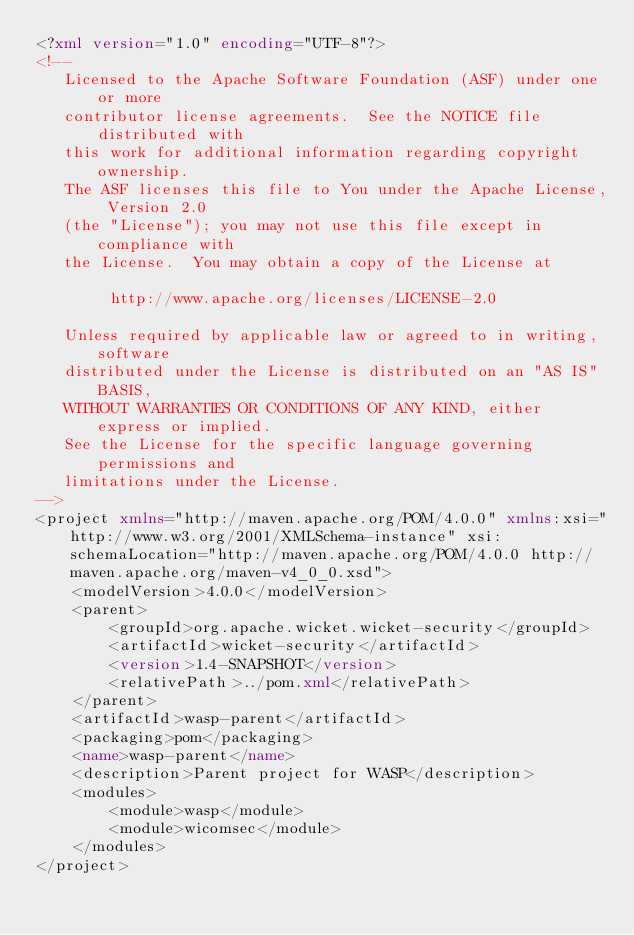Convert code to text. <code><loc_0><loc_0><loc_500><loc_500><_XML_><?xml version="1.0" encoding="UTF-8"?>
<!--
   Licensed to the Apache Software Foundation (ASF) under one or more
   contributor license agreements.  See the NOTICE file distributed with
   this work for additional information regarding copyright ownership.
   The ASF licenses this file to You under the Apache License, Version 2.0
   (the "License"); you may not use this file except in compliance with
   the License.  You may obtain a copy of the License at

        http://www.apache.org/licenses/LICENSE-2.0

   Unless required by applicable law or agreed to in writing, software
   distributed under the License is distributed on an "AS IS" BASIS,
   WITHOUT WARRANTIES OR CONDITIONS OF ANY KIND, either express or implied.
   See the License for the specific language governing permissions and
   limitations under the License.
-->
<project xmlns="http://maven.apache.org/POM/4.0.0" xmlns:xsi="http://www.w3.org/2001/XMLSchema-instance" xsi:schemaLocation="http://maven.apache.org/POM/4.0.0 http://maven.apache.org/maven-v4_0_0.xsd">
	<modelVersion>4.0.0</modelVersion>
	<parent>
		<groupId>org.apache.wicket.wicket-security</groupId>
		<artifactId>wicket-security</artifactId>
		<version>1.4-SNAPSHOT</version>
		<relativePath>../pom.xml</relativePath>
	</parent>
	<artifactId>wasp-parent</artifactId>
	<packaging>pom</packaging>
	<name>wasp-parent</name>
	<description>Parent project for WASP</description>
	<modules>
		<module>wasp</module>
		<module>wicomsec</module>
	</modules>
</project>
</code> 